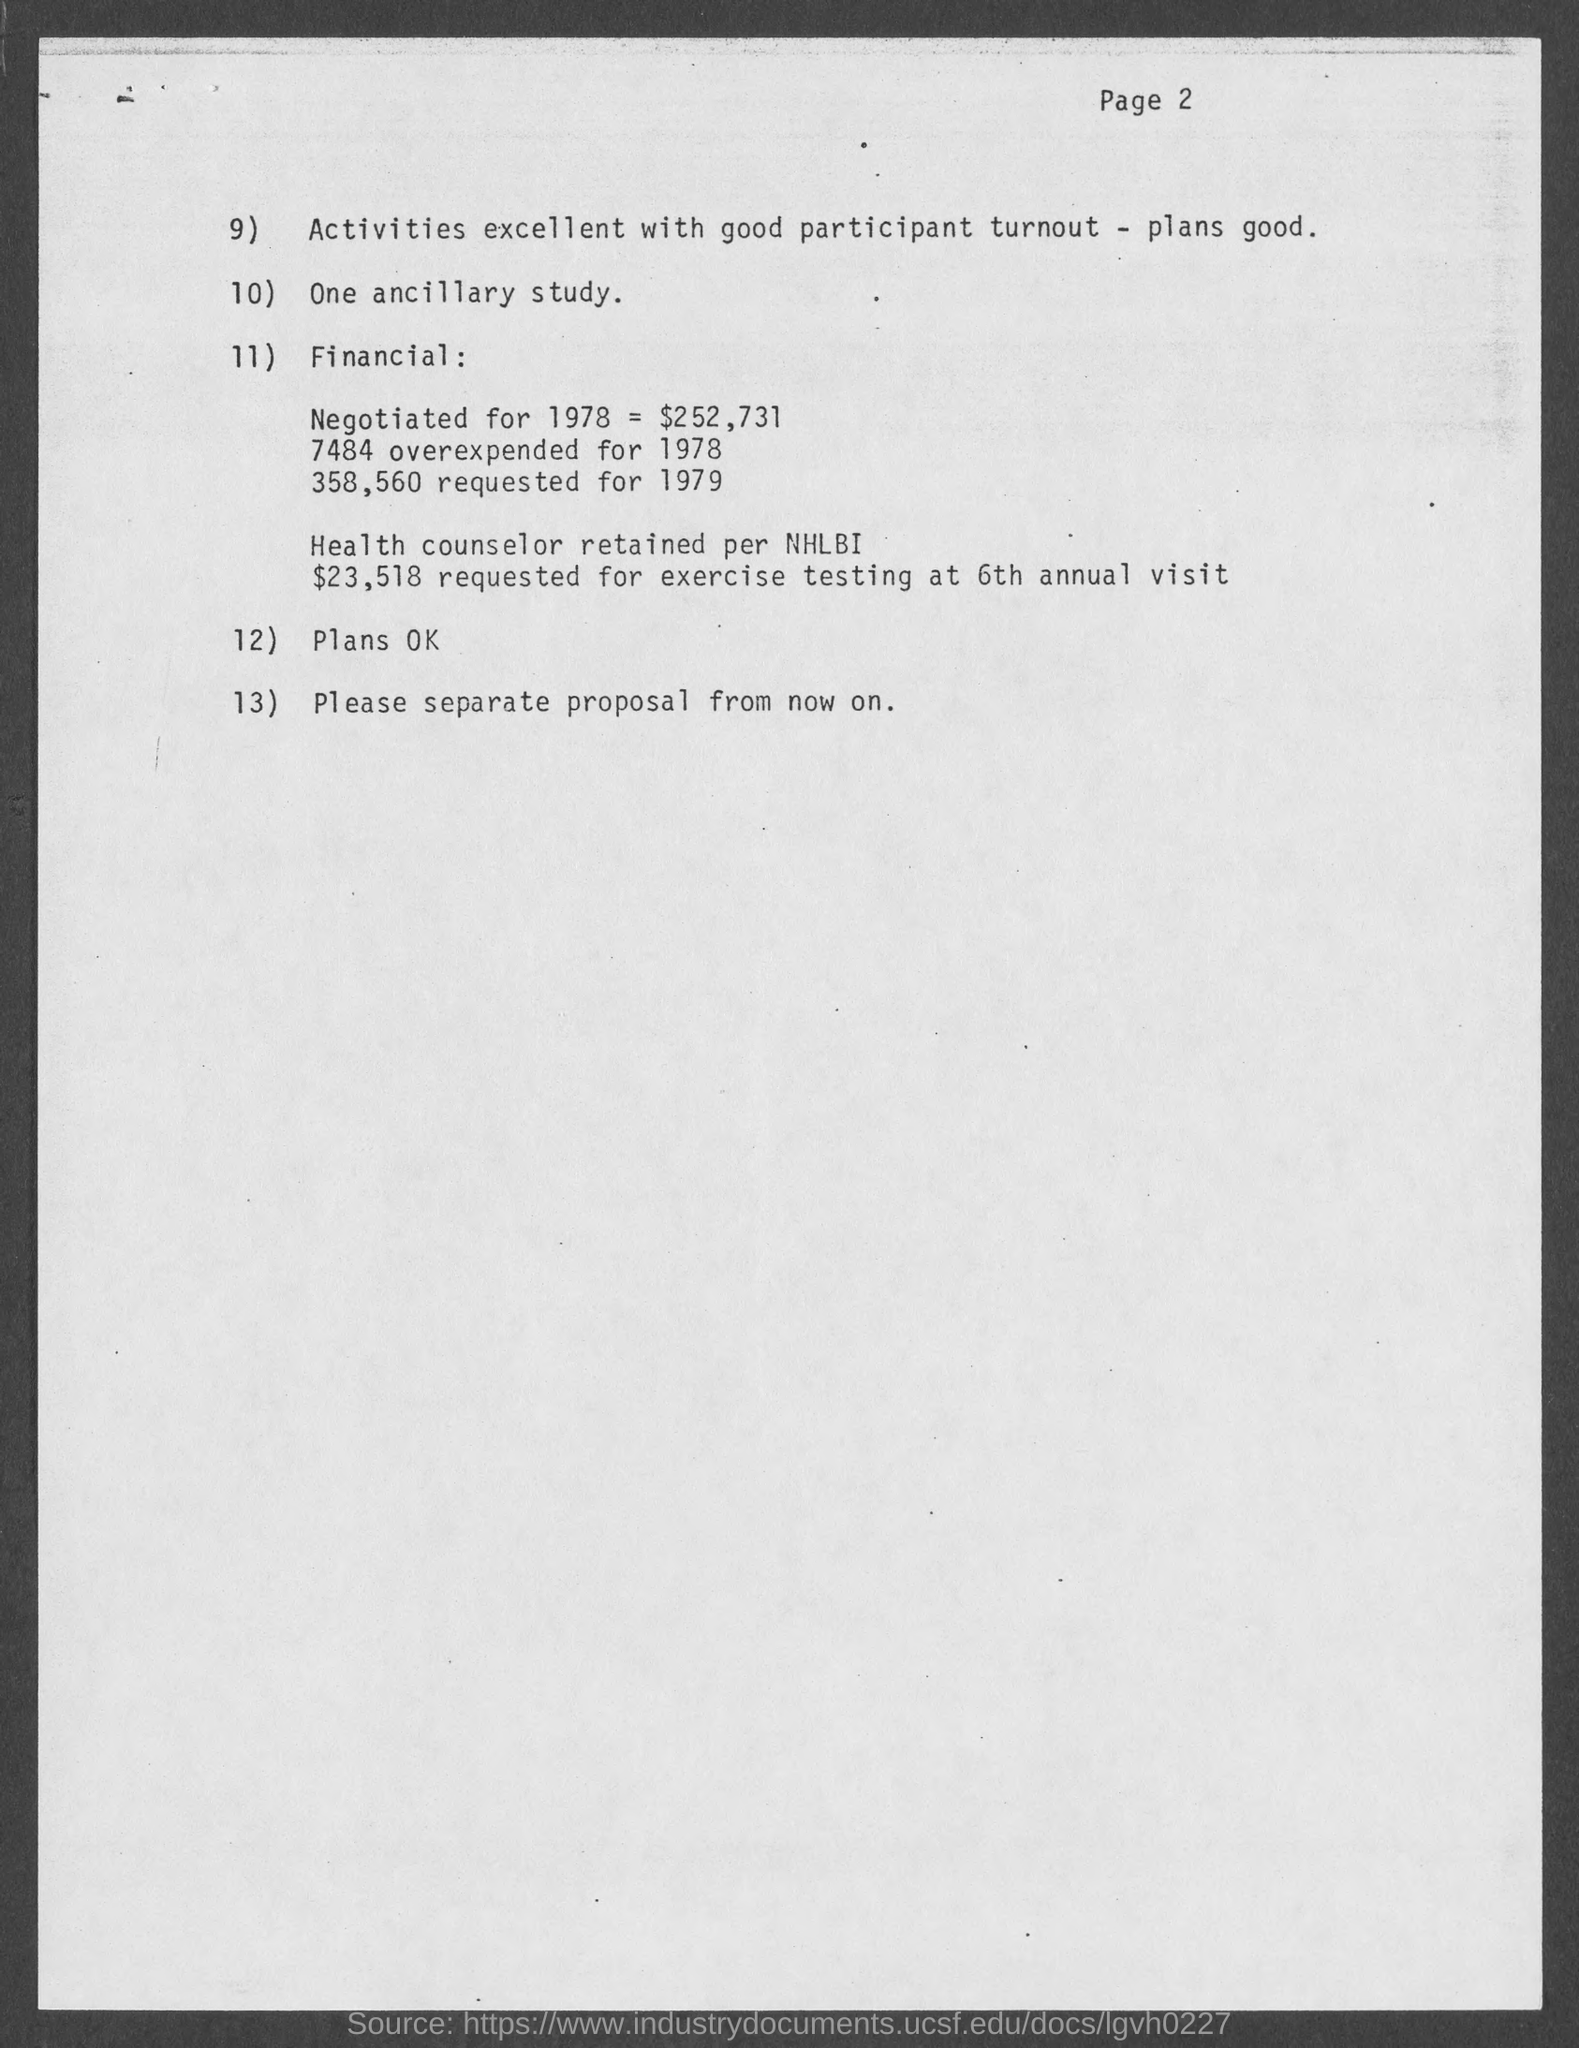Is there a mention of any staff or personnel in the text? Yes, the document mentions that a 'Health counselor retained per NHLBI' and alludes to exercise testing at a 6th annual visit, which suggests that staff was involved in a health-related capacity. What is NHLBI? NHLBI stands for National Heart, Lung, and Blood Institute, which is a part of the National Institutes of Health in the United States, focusing on research and education related to heart, lung, and blood diseases. 